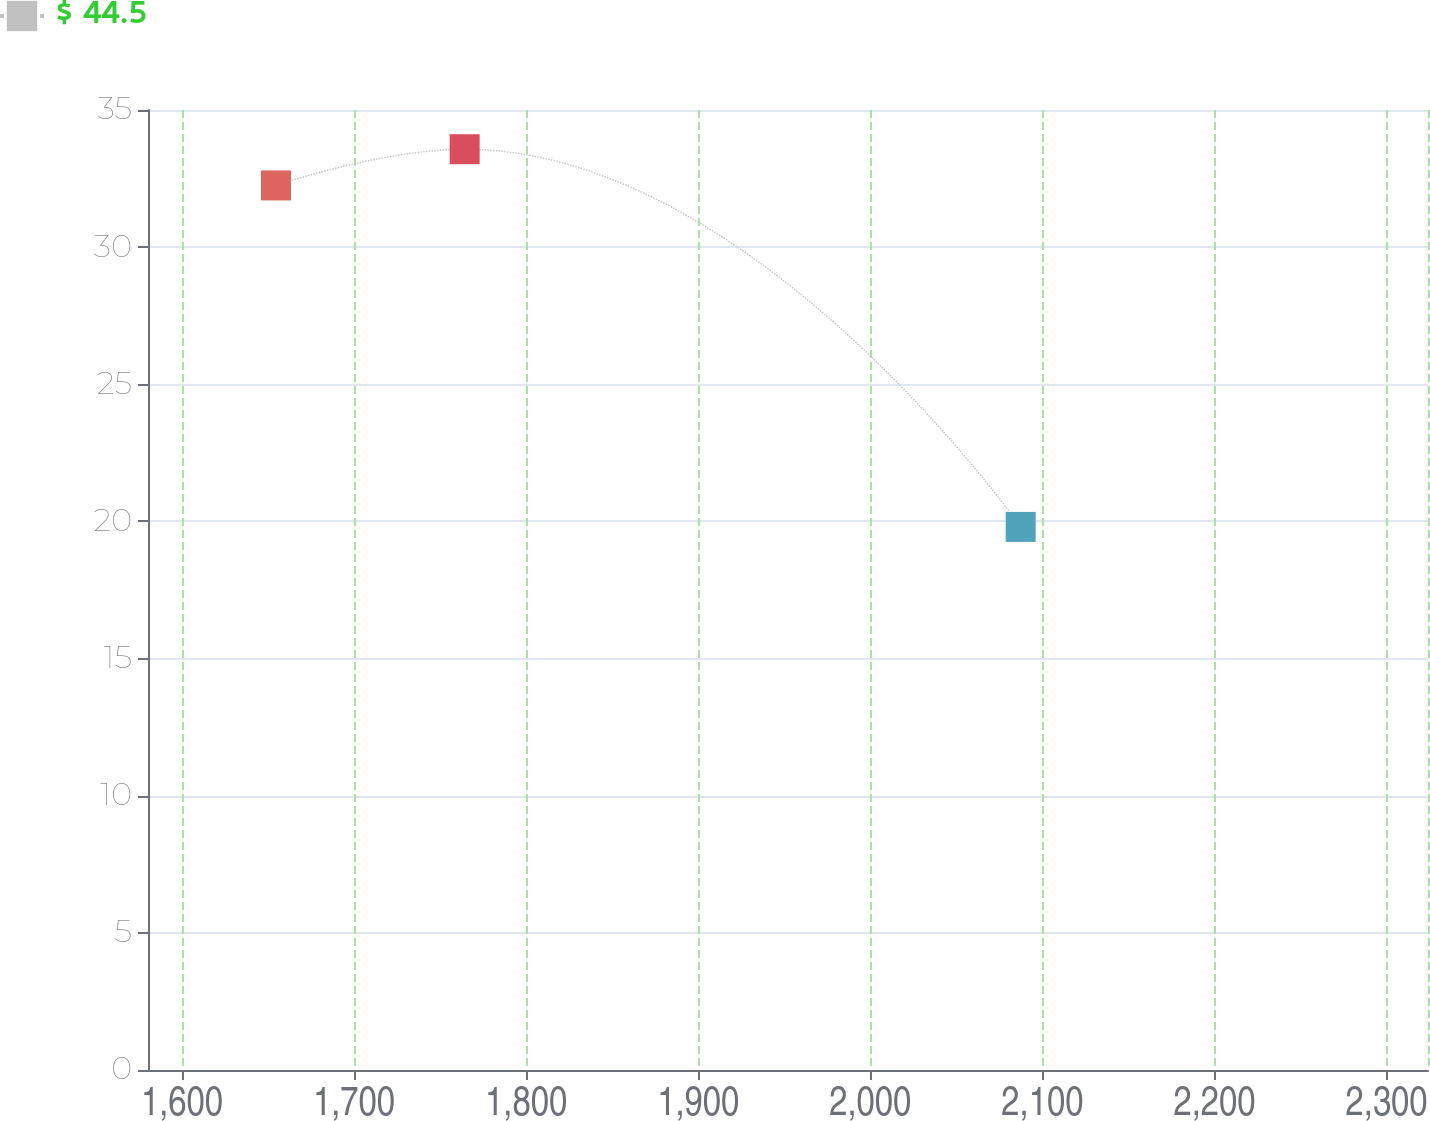Convert chart. <chart><loc_0><loc_0><loc_500><loc_500><line_chart><ecel><fcel>$ 44.5<nl><fcel>1654.66<fcel>32.25<nl><fcel>1764.28<fcel>33.57<nl><fcel>2087.4<fcel>19.8<nl><fcel>2398.46<fcel>22.45<nl></chart> 